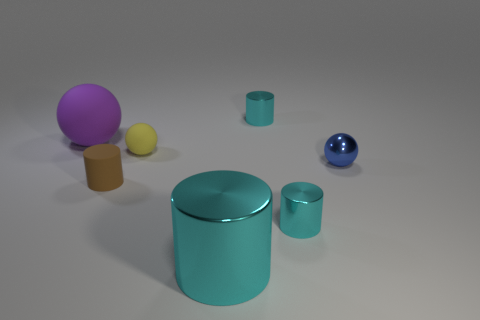Are there more balls that are to the right of the small yellow rubber thing than purple spheres?
Your answer should be compact. No. What shape is the yellow thing that is made of the same material as the purple sphere?
Offer a terse response. Sphere. There is a big object in front of the tiny thing that is left of the small yellow thing; what color is it?
Offer a very short reply. Cyan. Does the large matte object have the same shape as the brown matte object?
Provide a succinct answer. No. What material is the other small thing that is the same shape as the tiny yellow matte object?
Keep it short and to the point. Metal. There is a shiny cylinder left of the cyan metal object that is behind the large matte thing; is there a large cyan thing right of it?
Give a very brief answer. No. Is the shape of the purple object the same as the tiny shiny thing in front of the blue thing?
Provide a short and direct response. No. Is there any other thing that is the same color as the large ball?
Give a very brief answer. No. There is a rubber thing that is on the right side of the tiny rubber cylinder; is it the same color as the metallic cylinder that is behind the matte cylinder?
Make the answer very short. No. Are there any tiny blue spheres?
Ensure brevity in your answer.  Yes. 